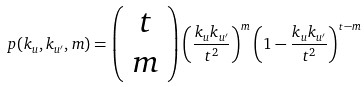Convert formula to latex. <formula><loc_0><loc_0><loc_500><loc_500>p ( k _ { u } , k _ { u ^ { \prime } } , m ) = \left ( \begin{array} { c } t \\ m \end{array} \right ) \left ( \frac { k _ { u } k _ { u ^ { \prime } } } { t ^ { 2 } } \right ) ^ { m } \left ( 1 - \frac { k _ { u } k _ { u ^ { \prime } } } { t ^ { 2 } } \right ) ^ { t - m } \</formula> 